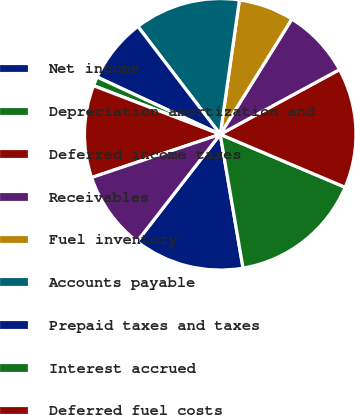<chart> <loc_0><loc_0><loc_500><loc_500><pie_chart><fcel>Net income<fcel>Depreciation amortization and<fcel>Deferred income taxes<fcel>Receivables<fcel>Fuel inventory<fcel>Accounts payable<fcel>Prepaid taxes and taxes<fcel>Interest accrued<fcel>Deferred fuel costs<fcel>Other working capital accounts<nl><fcel>13.19%<fcel>15.93%<fcel>14.29%<fcel>8.24%<fcel>6.59%<fcel>12.64%<fcel>7.69%<fcel>1.1%<fcel>10.99%<fcel>9.34%<nl></chart> 